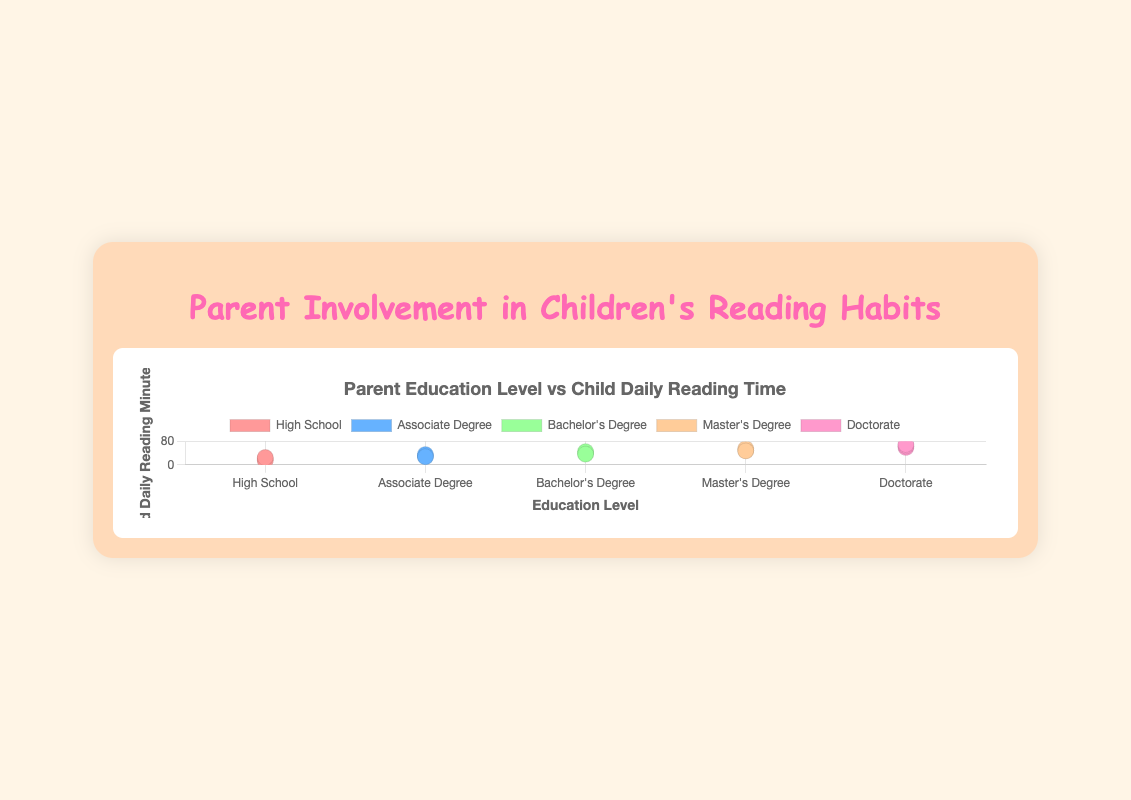How many data points represent parents with a Master's Degree? Count the data points designated by "Master's Degree" in the legend or on the plot. There are 3 data points: Jack Thompson, Kathy Clark, and Leo Lewis.
Answer: 3 Which education level has the highest range in Child Daily Reading Minutes? Compare the minimum and maximum reading minutes for each education level. The biggest range appears in "Doctorate" with a range of 60 to 70 minutes.
Answer: Doctorate What is the average Child Daily Reading Minutes for parents with a Bachelor's Degree? Add the reading minutes for Grace Martinez (40), Henry Wilson (45), and Ivy Lee (37), then divide by 3. (40 + 45 + 37) / 3 = 122 / 3 = 40.67
Answer: 40.67 Is there a visual trend that indicates higher education levels correspond to more Child Daily Reading Minutes? Visually assess the grouped scatter plot from left to right. You can see that the average Child Daily Reading Minutes increase as you move from "High School" to "Doctorate."
Answer: Yes Which parent’s child reads the least daily? Identify which data point has the lowest y-value on the plot. Bob Smith's child reads 15 minutes daily, the lowest in the dataset.
Answer: Bob Smith What is the total Child Daily Reading Minutes for all children of parents with an Associate Degree? Add reading minutes for David Brown (30), Emma Davis (35), and Frank Harris (28). 30 + 35 + 28 = 93
Answer: 93 Compare the Child Daily Reading Minutes of parents with a Doctorate to those with a High School education. Which group reads more on average? Calculate the average Child Daily Reading Minutes for "Doctorate": (60 + 65 + 70) / 3 = 65 minutes. For "High School": (20 + 15 + 25) / 3 = 20 minutes. Doctorate has a higher average.
Answer: Doctorate Which parent's child reads 65 minutes daily? Locate the data point at y=65. According to the chart, it's Nathan Young.
Answer: Nathan Young What is the median Child Daily Reading Minutes for all children of parents with a Master's Degree? List the reading minutes in ascending order: 48, 50, 55. The middle value is 50.
Answer: 50 Identify the parent with the highest education level whose child reads exactly 40 minutes daily. Locate the parent within the dataset or on the scatter plot with x corresponding to Bachelor's Degree and y=40. It's Grace Martinez.
Answer: Grace Martinez 